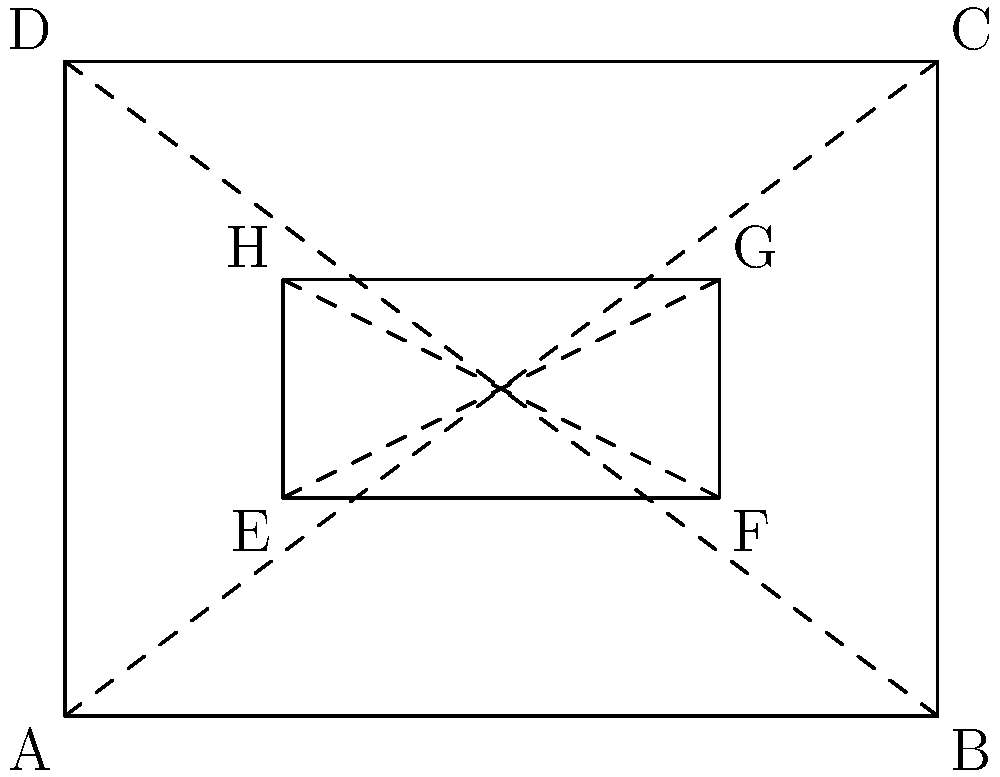In our new Scout badge design, we have two rectangles ABCD and EFGH as shown. If EFGH is similar to ABCD with a scale factor of $\frac{1}{2}$, what is the ratio of the area of EFGH to the area of ABCD? Let's approach this step-by-step:

1) First, recall that if two rectangles are similar with a scale factor of $k$, then:
   - The ratio of their corresponding sides is $k$
   - The ratio of their areas is $k^2$

2) In this case, the scale factor is $\frac{1}{2}$

3) Therefore, the ratio of the areas will be:
   $$\left(\frac{1}{2}\right)^2 = \frac{1}{4}$$

4) This means that the area of EFGH is $\frac{1}{4}$ of the area of ABCD

5) We can express this as a ratio:
   Area of EFGH : Area of ABCD = 1 : 4

Thus, the ratio of the area of EFGH to the area of ABCD is 1:4.
Answer: 1:4 